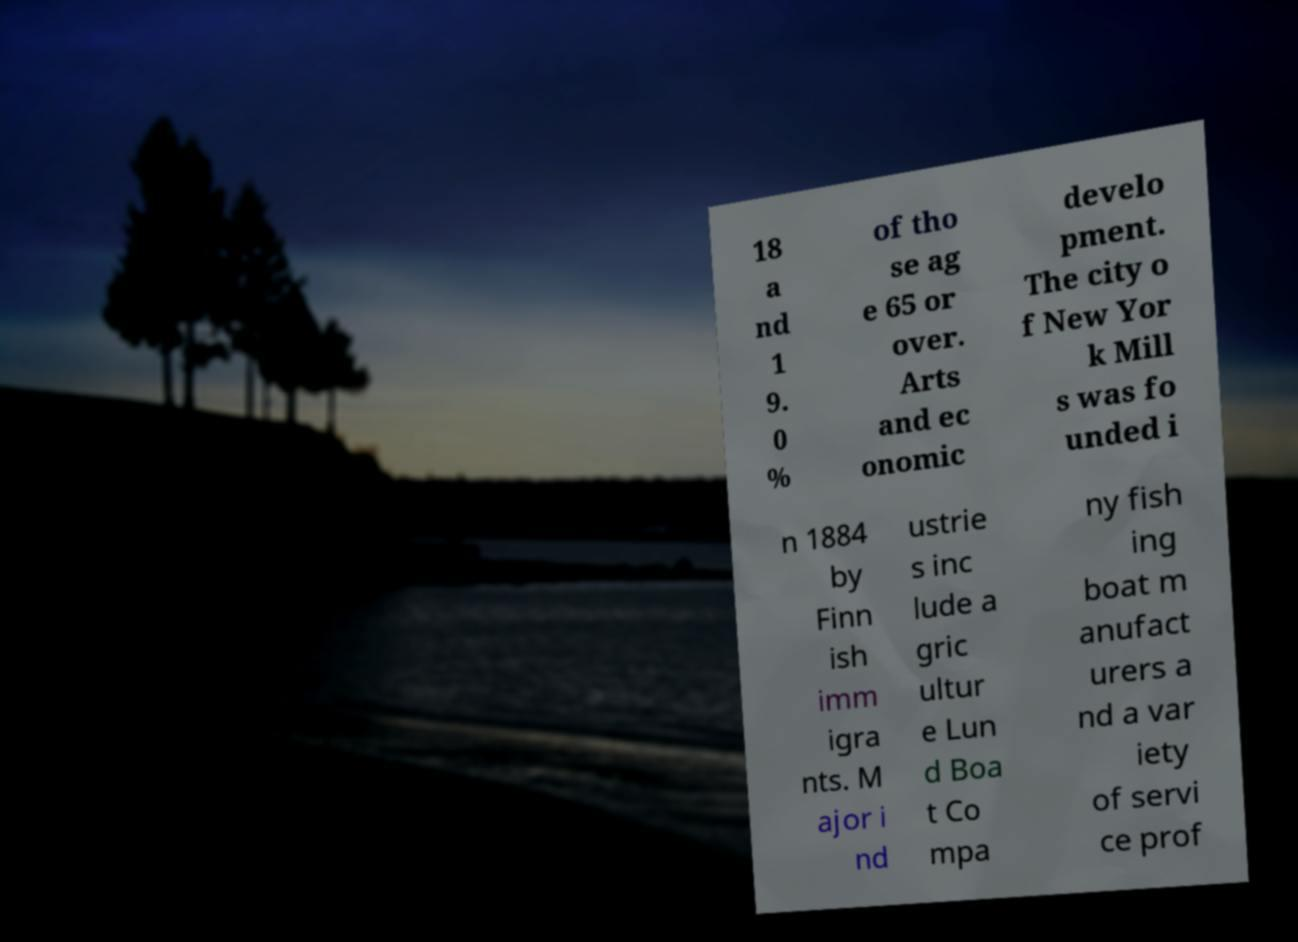There's text embedded in this image that I need extracted. Can you transcribe it verbatim? 18 a nd 1 9. 0 % of tho se ag e 65 or over. Arts and ec onomic develo pment. The city o f New Yor k Mill s was fo unded i n 1884 by Finn ish imm igra nts. M ajor i nd ustrie s inc lude a gric ultur e Lun d Boa t Co mpa ny fish ing boat m anufact urers a nd a var iety of servi ce prof 